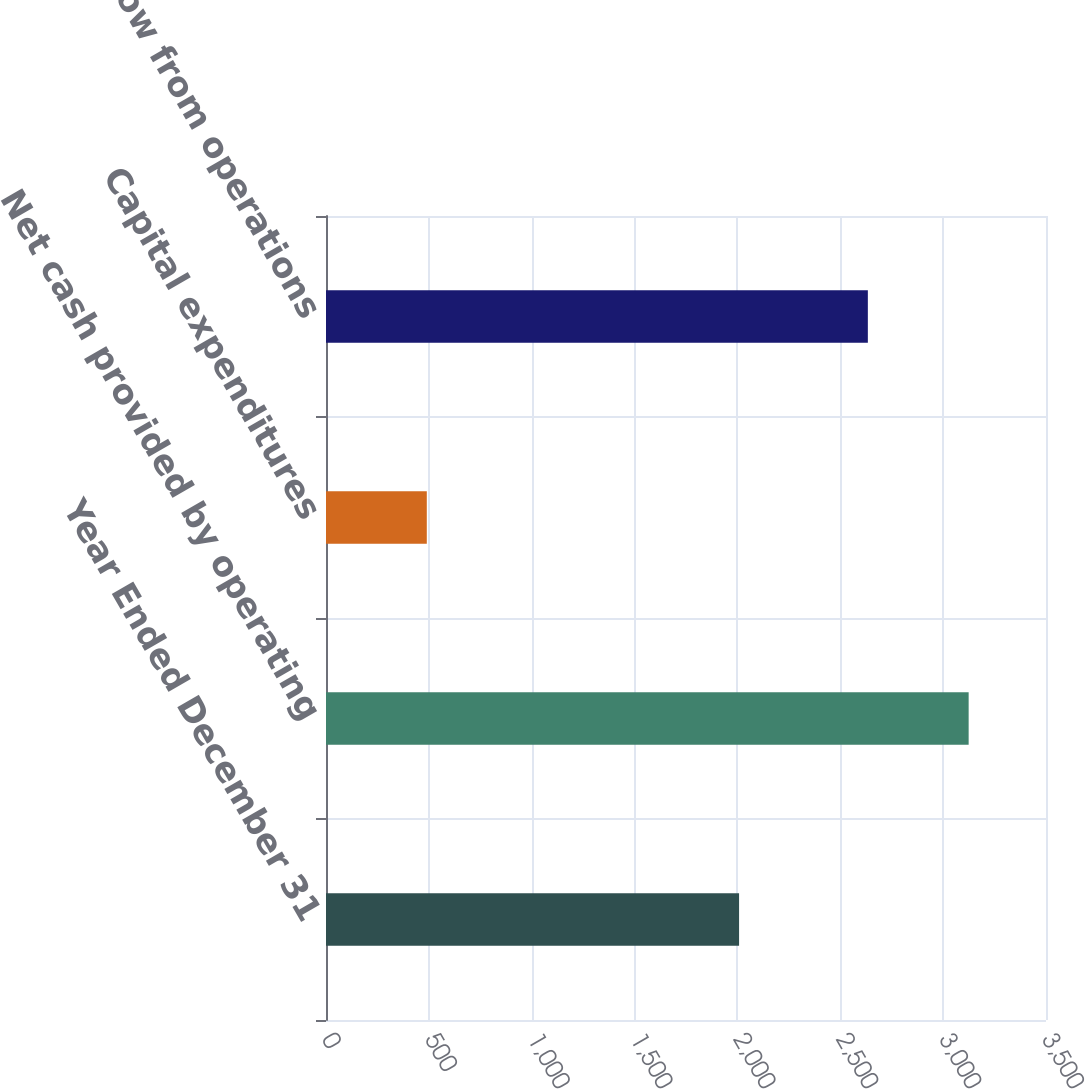<chart> <loc_0><loc_0><loc_500><loc_500><bar_chart><fcel>Year Ended December 31<fcel>Net cash provided by operating<fcel>Capital expenditures<fcel>Free cash flow from operations<nl><fcel>2008<fcel>3124<fcel>490<fcel>2634<nl></chart> 